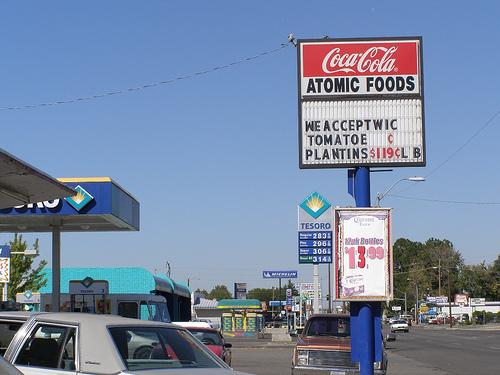What type of location does this image portray and what are some major features? The image depicts a gas station, featuring cars, a blue awning, price sign, blue post, and a nearby green building. Write a brief report describing the central objects and their respective positions in the image. The image showcases a gas station with cars positioned around it, a blue post nearby, a street light, and a green building on the periphery. Give a detailed account of the main parts of the image, including the colors and general atmosphere. The image shows a gas station scene with cars in different colors such as brown, silver, and red, blue awning, clear blue sky, green leaves on trees, and a blue sign post. Describe the general feeling or impression this image gives you. A bustling day at a gas station under a bright and clear sky, with cars coming and going, and various street signs scattered around. Mention the most significant elements in the image with brief descriptions. A clear blue sky, gas station with prices posted, cars, blue post, street light, and a green building. Briefly mention the most noticeable objects in the image, focusing on their colors. A clear blue sky, a blue awning and post, a green building, and cars in various shades like brown, silver, and red. Provide a concise summary of the scene in the image. A busy gas station with various cars under a clear blue sky, surrounded by street lights, blue posts, and a green building. Describe the subjects and environment in the image using colorful and vivid language. A bustling gas station teeming with vibrant cars of various hues, nestled under a vast, azure sky, surrounded by verdant foliage, and adorned with intriguing signs and posts. Express the content of the image as if you are describing it to someone who cannot see it. Picture a gas station with a blue awning, filled with different-colored cars, and surrounded by distinct elements like a street lamp, blue post, and a green building, all under a clear blue sky. Enumerate the primary colors in the image while highlighting notable objects of that color. Blue: sky, awning, post; Green: leaves, building; Brown: car, Red: car, numbers; Silver: car; White: sedan. 